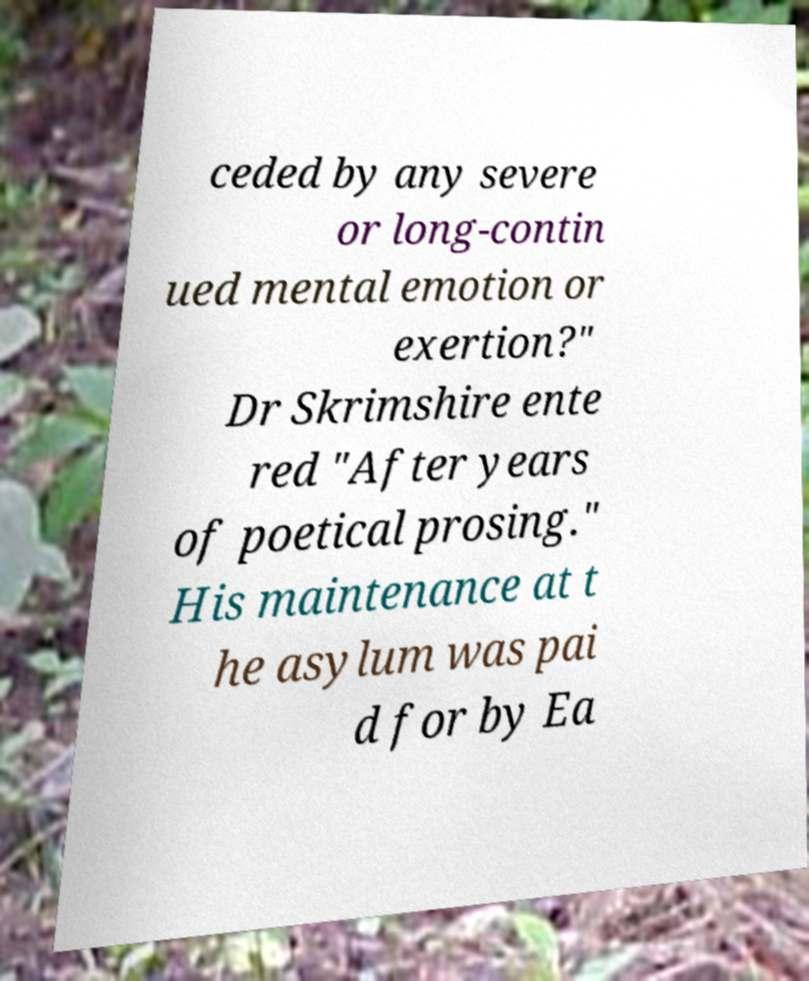Please identify and transcribe the text found in this image. ceded by any severe or long-contin ued mental emotion or exertion?" Dr Skrimshire ente red "After years of poetical prosing." His maintenance at t he asylum was pai d for by Ea 